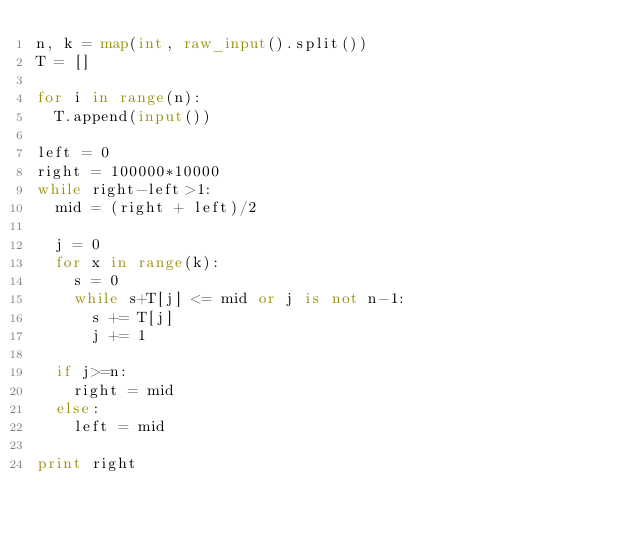Convert code to text. <code><loc_0><loc_0><loc_500><loc_500><_Python_>n, k = map(int, raw_input().split())
T = []

for i in range(n):
  T.append(input())

left = 0
right = 100000*10000
while right-left>1:
  mid = (right + left)/2

  j = 0
  for x in range(k):
    s = 0
    while s+T[j] <= mid or j is not n-1:
      s += T[j]
      j += 1

  if j>=n:
    right = mid
  else:
    left = mid

print right</code> 